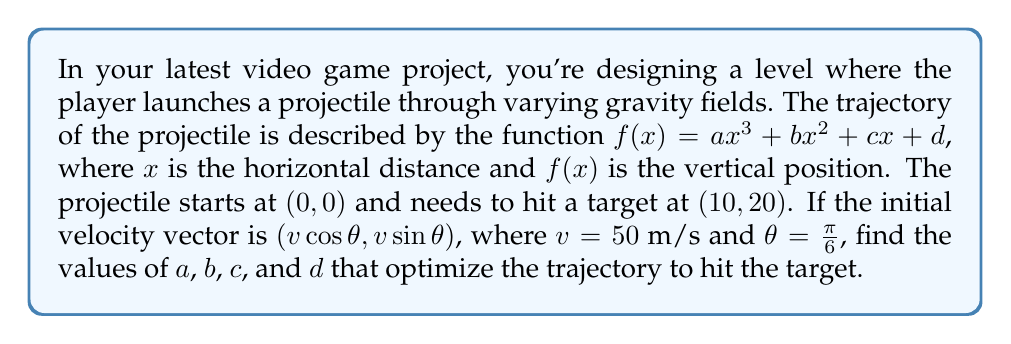Provide a solution to this math problem. Let's approach this step-by-step:

1) First, we know that the projectile starts at $(0,0)$, so $f(0) = d = 0$.

2) The projectile needs to hit the target at $(10,20)$, so $f(10) = 20$:

   $$20 = 1000a + 100b + 10c + d$$

3) The initial velocity components give us information about the initial slope of the trajectory:

   $$f'(0) = c = v \sin \theta = 50 \sin(\frac{\pi}{6}) = 25$$

4) We can also use the horizontal component of velocity to find the time it takes to reach $x=10$:

   $$t = \frac{10}{v \cos \theta} = \frac{10}{50 \cos(\frac{\pi}{6})} = \frac{2\sqrt{3}}{15}$$

5) The vertical component of velocity at $x=10$ should match the derivative of our function:

   $$f'(10) = 3a(10)^2 + 2b(10) + c = 50 \sin(\frac{\pi}{6}) = 25$$

6) Now we have a system of equations:

   $$d = 0$$
   $$1000a + 100b + 10c = 20$$
   $$c = 25$$
   $$300a + 20b + 25 = 25$$

7) Solving this system:
   From the last equation: $300a + 20b = 0$, or $15a + b = 0$
   Substituting into the second equation:
   $$1000a + 100(-15a) + 250 = 20$$
   $$500a = -230$$
   $$a = -0.46$$

   Then:
   $$b = -15a = 6.9$$
   $$c = 25$$
   $$d = 0$$

8) These values of $a$, $b$, $c$, and $d$ optimize the trajectory to hit the target given the initial conditions.
Answer: $a = -0.46$, $b = 6.9$, $c = 25$, $d = 0$ 